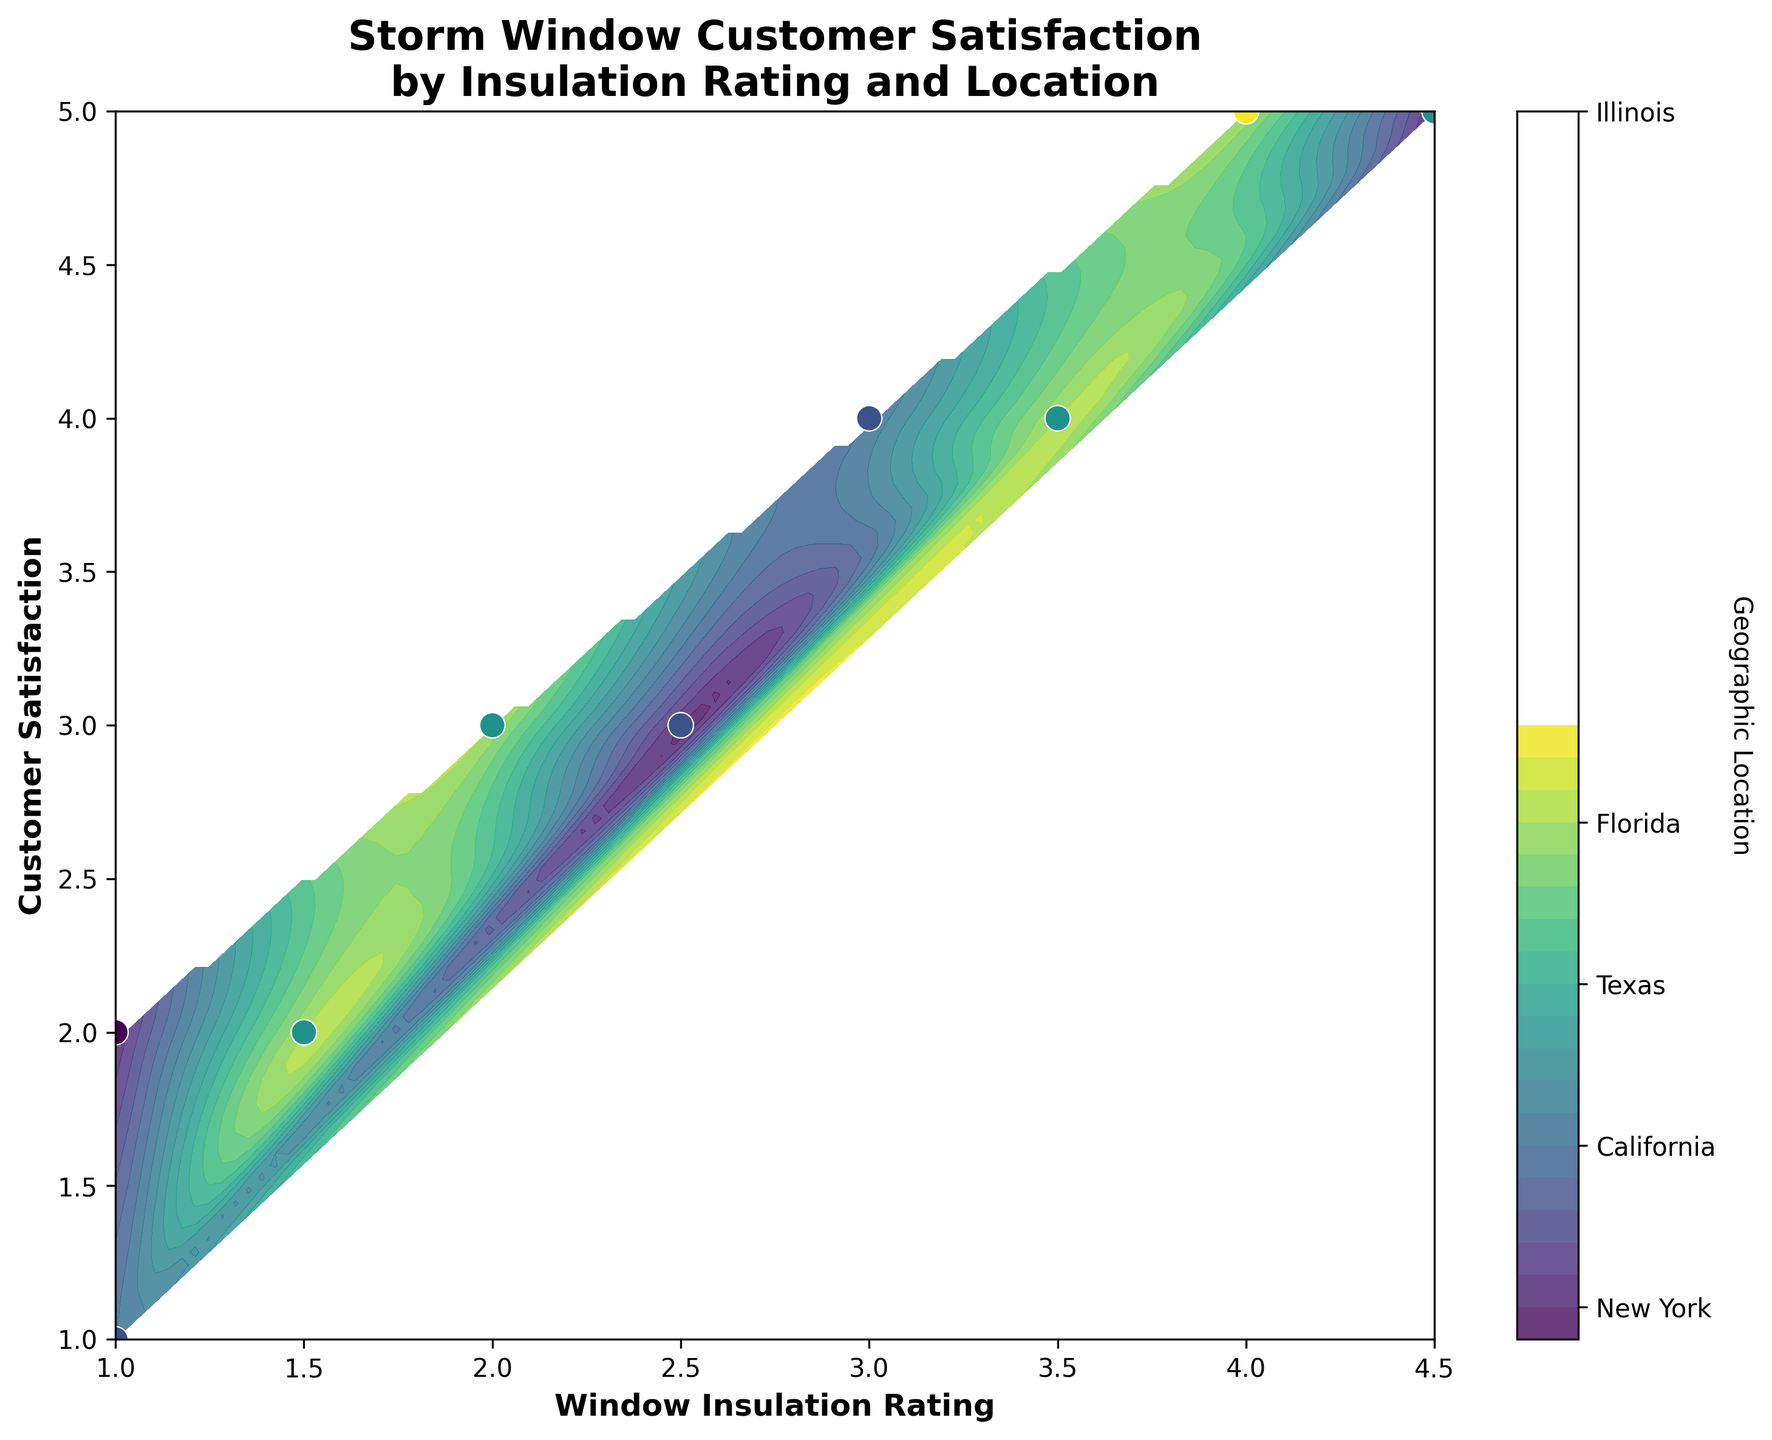What is the title of the plot? The title is prominently displayed at the top of the plot, reading "Storm Window Customer Satisfaction by Insulation Rating and Location".
Answer: Storm Window Customer Satisfaction by Insulation Rating and Location What are the axes labels? The x-axis is labeled "Window Insulation Rating" and the y-axis is labeled "Customer Satisfaction". These labels help in identifying what each axis represents in the plot.
Answer: Window Insulation Rating (x-axis), Customer Satisfaction (y-axis) How many levels are used in the contour plot? Observing the legend or color bar, there are 20 levels delineated by gradations in color. This is derived from the code snippet where 20 levels are specified.
Answer: 20 Which location has the highest overall customer satisfaction? Looking at the plot, the highest customer satisfaction values are heavily concentrated towards the upper end of the y-axis. By observing the scatter points' colors corresponding to locations, we see that Florida has the highest concentration in this region.
Answer: Florida Which window insulation rating shows the most variation in customer satisfaction across different locations? By analyzing the spread of customer satisfaction values (y-axis) for each window insulation rating (x-axis), the rating 2.0 shows the widest spread across different satisfaction levels, indicating significant variation.
Answer: 2.0 Is there a correlation between window insulation rating and customer satisfaction? The scatter points tend to cluster diagonally from the lower-left to the upper-right, indicating a positive correlation: as window insulation rating increases, customer satisfaction also tends to increase.
Answer: Yes, there is a positive correlation Which combination of window insulation rating and geographic location yields an average customer satisfaction of 4? From the contour plot, we can observe that a window insulation rating around 3.5 in New York and Illinois provides a customer satisfaction level very close to 4.
Answer: Window Insulation Rating 3.5, Geographic Location New York or Illinois Do any locations exhibit low customer satisfaction consistently regardless of window insulation rating? By observing color patterns associated with lower customer satisfaction levels (bottom of the y-axis), Texas seems to have a consistently lower customer satisfaction compared to other locations, irrespective of the window insulation rating.
Answer: Texas 